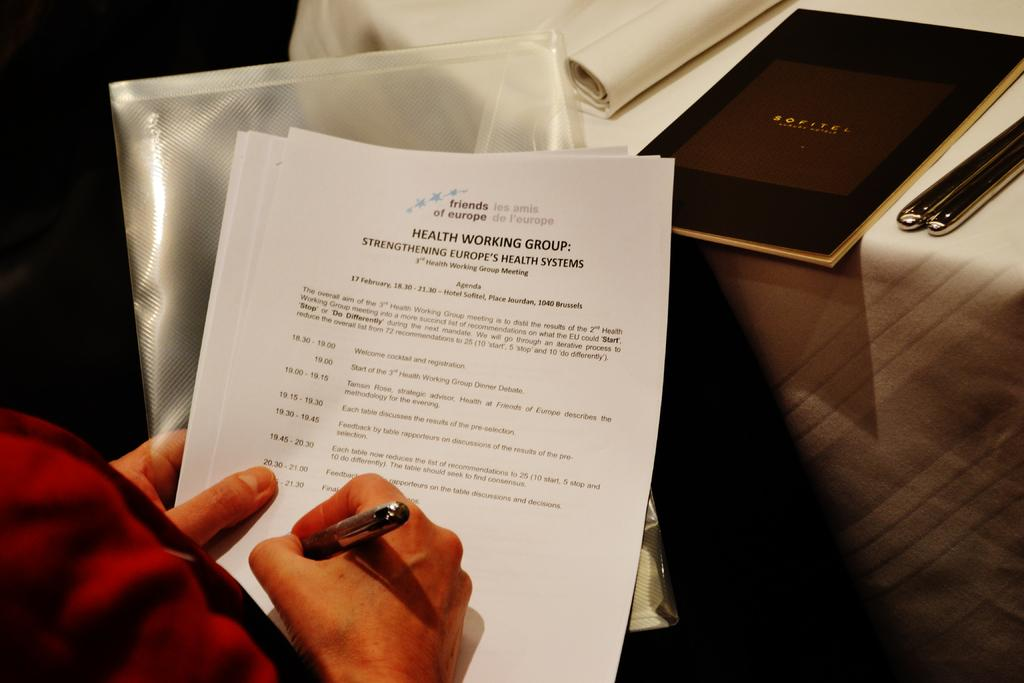<image>
Create a compact narrative representing the image presented. someone filling out paperwork titled : Health working group 